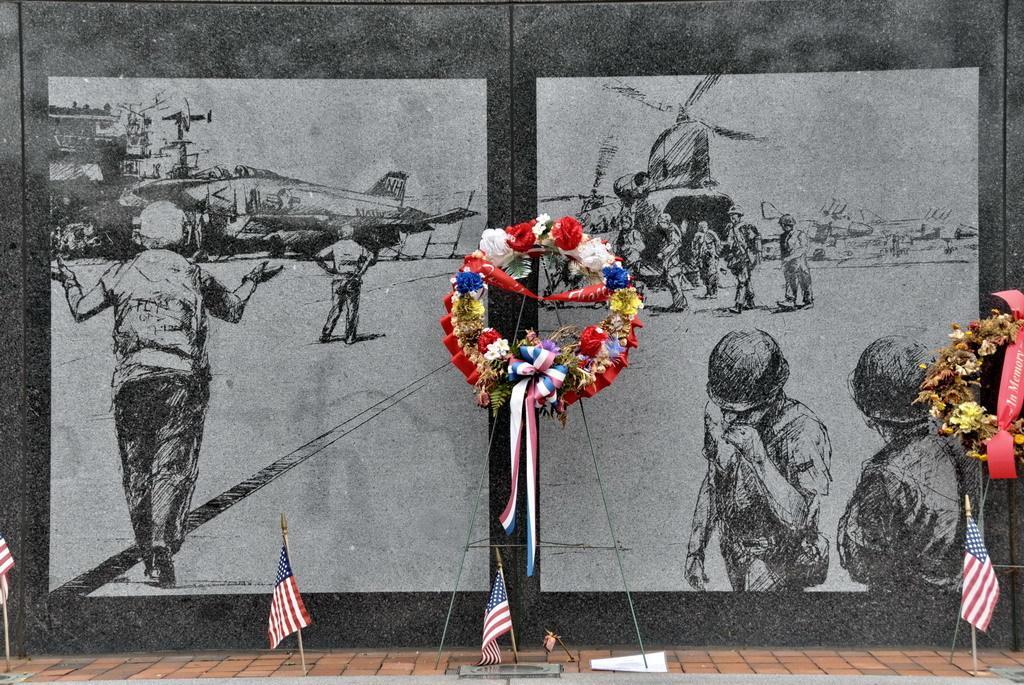Can you describe this image briefly? In this image we can see drawings of helicopter, persons and sky. At the bottom of the image we can see flags. In the center of the image there is garland. 